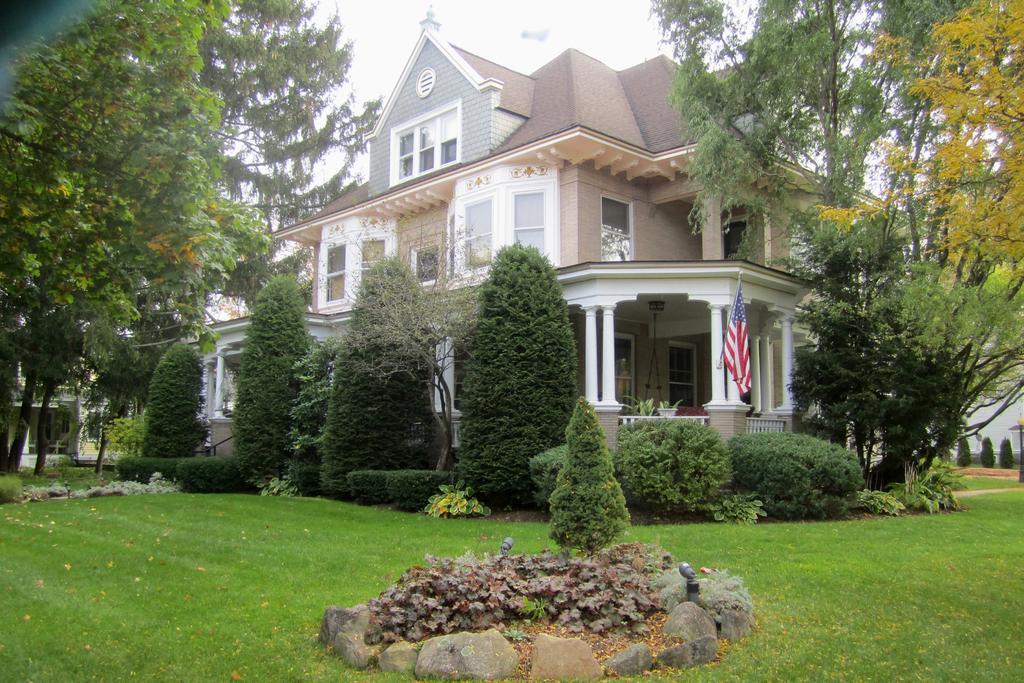Can you describe this image briefly? In this picture, we can see a building with doors and windows, we can see some trees, plants, stones on the ground covered with grass and we can see the sky. 